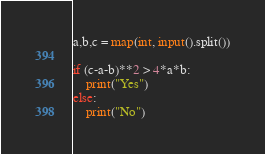Convert code to text. <code><loc_0><loc_0><loc_500><loc_500><_Python_>a,b,c = map(int, input().split())

if (c-a-b)**2 > 4*a*b:
    print("Yes")
else:
    print("No")</code> 